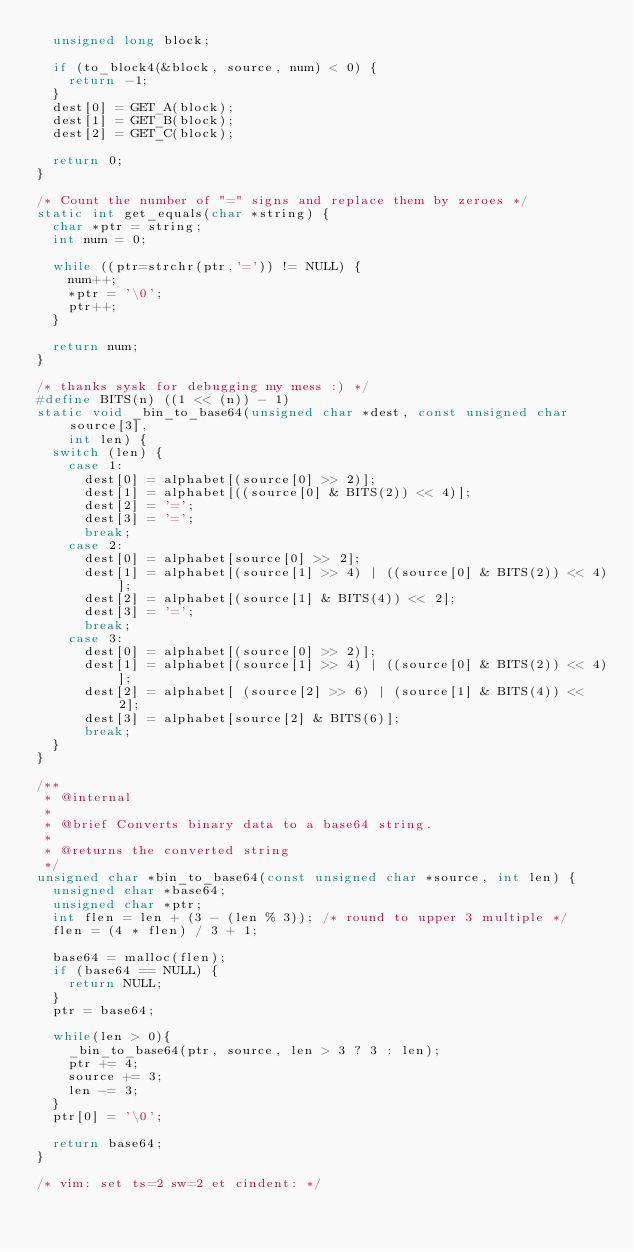Convert code to text. <code><loc_0><loc_0><loc_500><loc_500><_C_>  unsigned long block;

  if (to_block4(&block, source, num) < 0) {
    return -1;
  }
  dest[0] = GET_A(block);
  dest[1] = GET_B(block);
  dest[2] = GET_C(block);

  return 0;
}

/* Count the number of "=" signs and replace them by zeroes */
static int get_equals(char *string) {
  char *ptr = string;
  int num = 0;

  while ((ptr=strchr(ptr,'=')) != NULL) {
    num++;
    *ptr = '\0';
    ptr++;
  }

  return num;
}

/* thanks sysk for debugging my mess :) */
#define BITS(n) ((1 << (n)) - 1)
static void _bin_to_base64(unsigned char *dest, const unsigned char source[3],
    int len) {
  switch (len) {
    case 1:
      dest[0] = alphabet[(source[0] >> 2)];
      dest[1] = alphabet[((source[0] & BITS(2)) << 4)];
      dest[2] = '=';
      dest[3] = '=';
      break;
    case 2:
      dest[0] = alphabet[source[0] >> 2];
      dest[1] = alphabet[(source[1] >> 4) | ((source[0] & BITS(2)) << 4)];
      dest[2] = alphabet[(source[1] & BITS(4)) << 2];
      dest[3] = '=';
      break;
    case 3:
      dest[0] = alphabet[(source[0] >> 2)];
      dest[1] = alphabet[(source[1] >> 4) | ((source[0] & BITS(2)) << 4)];
      dest[2] = alphabet[ (source[2] >> 6) | (source[1] & BITS(4)) << 2];
      dest[3] = alphabet[source[2] & BITS(6)];
      break;
  }
}

/**
 * @internal
 *
 * @brief Converts binary data to a base64 string.
 *
 * @returns the converted string
 */
unsigned char *bin_to_base64(const unsigned char *source, int len) {
  unsigned char *base64;
  unsigned char *ptr;
  int flen = len + (3 - (len % 3)); /* round to upper 3 multiple */
  flen = (4 * flen) / 3 + 1;

  base64 = malloc(flen);
  if (base64 == NULL) {
    return NULL;
  }
  ptr = base64;

  while(len > 0){
    _bin_to_base64(ptr, source, len > 3 ? 3 : len);
    ptr += 4;
    source += 3;
    len -= 3;
  }
  ptr[0] = '\0';

  return base64;
}

/* vim: set ts=2 sw=2 et cindent: */
</code> 